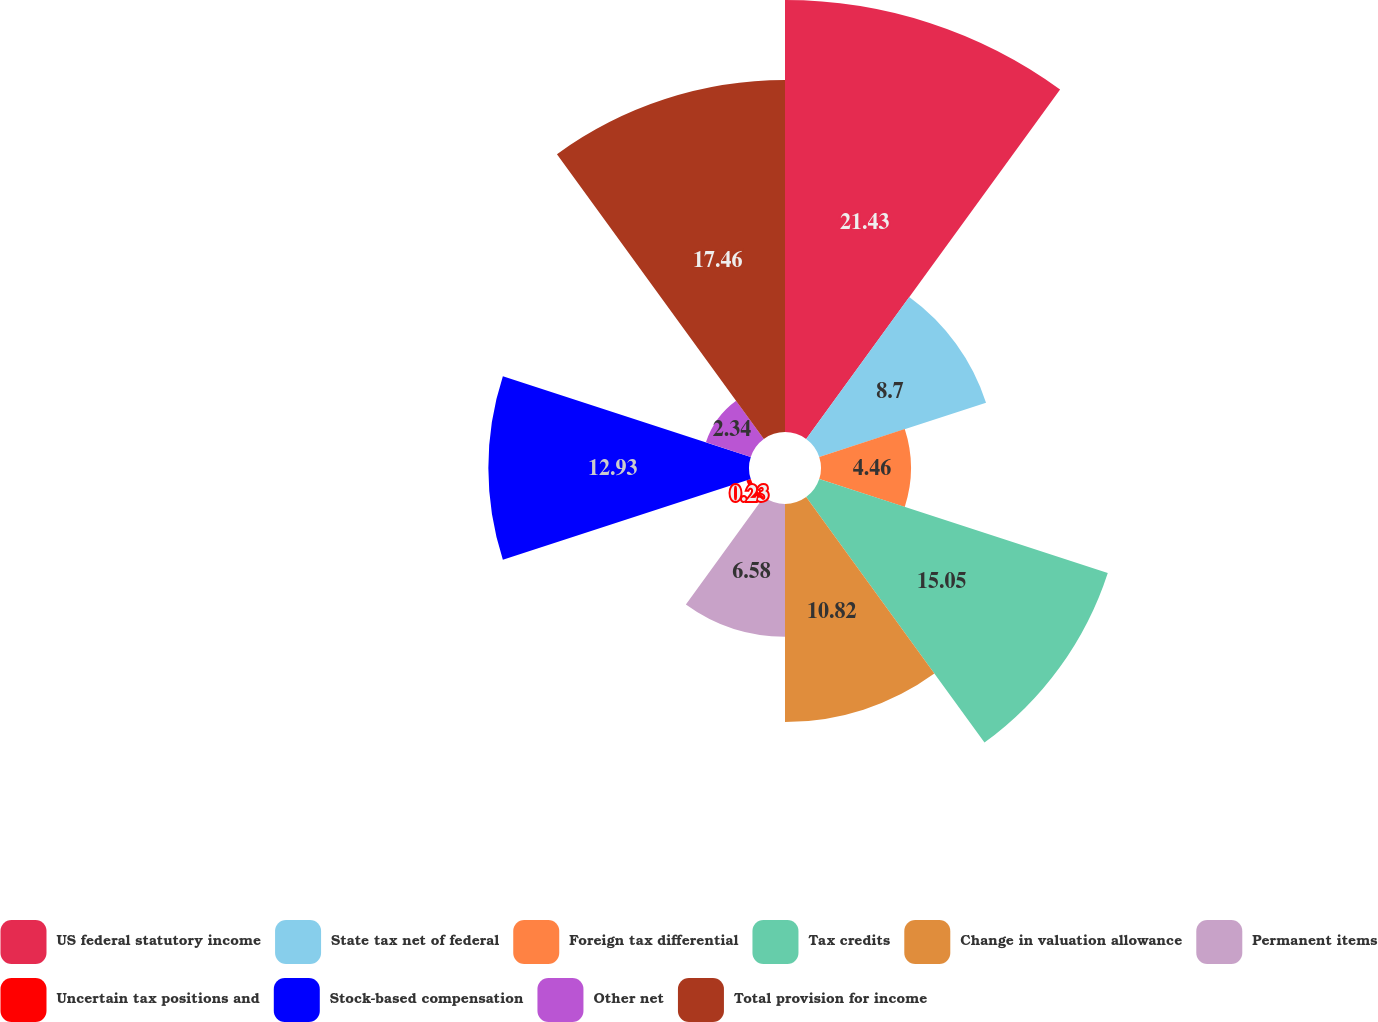<chart> <loc_0><loc_0><loc_500><loc_500><pie_chart><fcel>US federal statutory income<fcel>State tax net of federal<fcel>Foreign tax differential<fcel>Tax credits<fcel>Change in valuation allowance<fcel>Permanent items<fcel>Uncertain tax positions and<fcel>Stock-based compensation<fcel>Other net<fcel>Total provision for income<nl><fcel>21.43%<fcel>8.7%<fcel>4.46%<fcel>15.05%<fcel>10.82%<fcel>6.58%<fcel>0.23%<fcel>12.93%<fcel>2.34%<fcel>17.46%<nl></chart> 